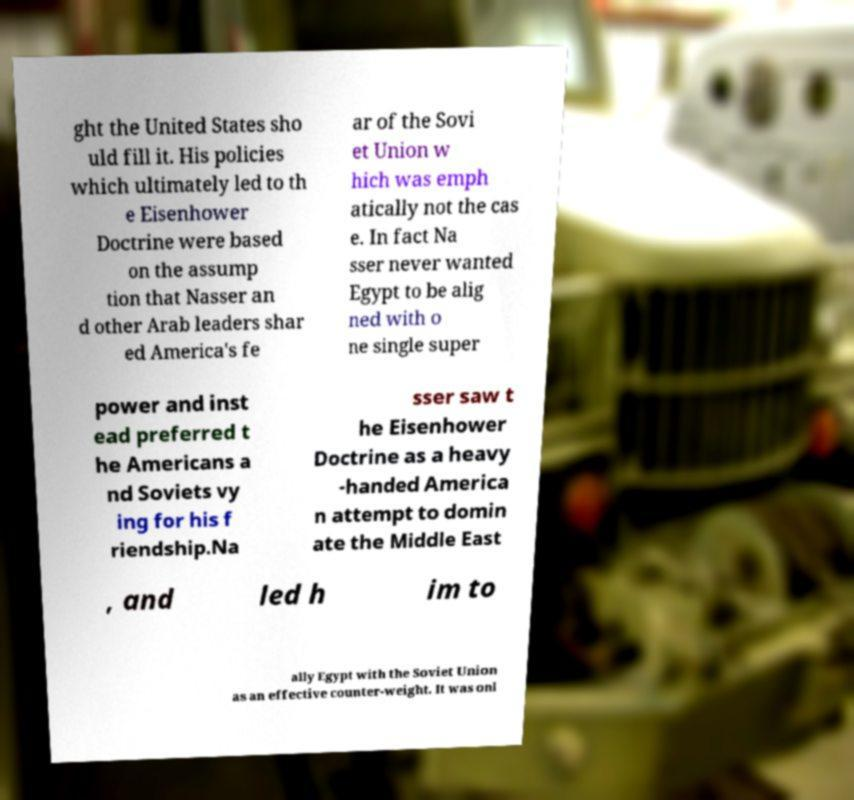Please read and relay the text visible in this image. What does it say? ght the United States sho uld fill it. His policies which ultimately led to th e Eisenhower Doctrine were based on the assump tion that Nasser an d other Arab leaders shar ed America's fe ar of the Sovi et Union w hich was emph atically not the cas e. In fact Na sser never wanted Egypt to be alig ned with o ne single super power and inst ead preferred t he Americans a nd Soviets vy ing for his f riendship.Na sser saw t he Eisenhower Doctrine as a heavy -handed America n attempt to domin ate the Middle East , and led h im to ally Egypt with the Soviet Union as an effective counter-weight. It was onl 